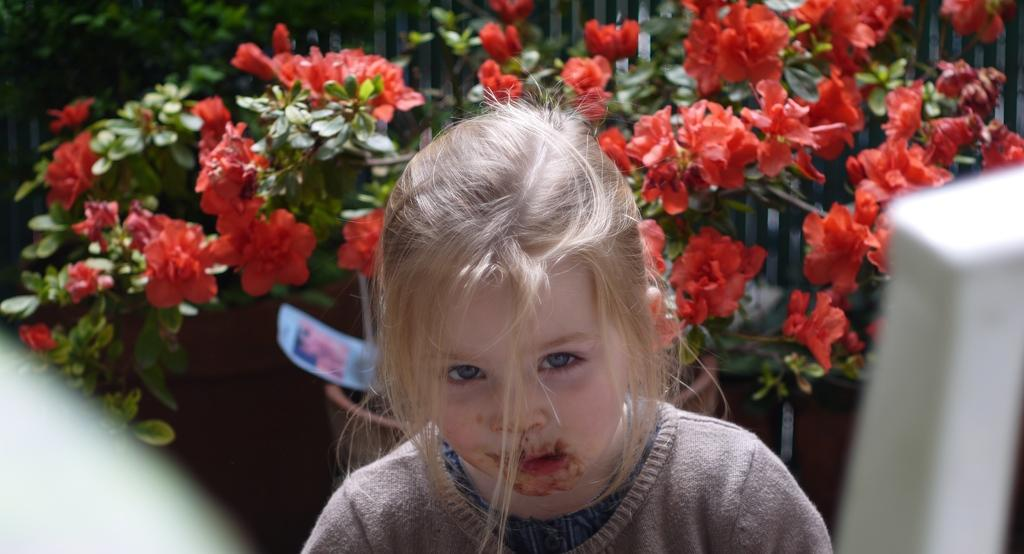What is the main subject in the middle of the image? There is a kid in the middle of the image. What can be seen in the background of the image? There are plants with flowers in the background of the image. How many snakes are wrapped around the kid in the image? There are no snakes present in the image; the kid is not interacting with any snakes. Is the girl in the image wearing a hat? There is no mention of a girl in the image, only a kid. 